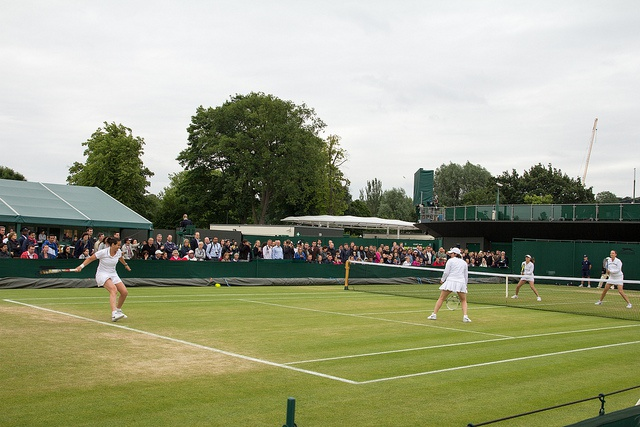Describe the objects in this image and their specific colors. I can see people in white, lightgray, gray, darkgray, and tan tones, people in white, lavender, olive, gray, and darkgray tones, people in white, lightgray, darkgray, tan, and gray tones, people in white, lightgray, darkgray, and olive tones, and people in white, black, gray, and darkgray tones in this image. 